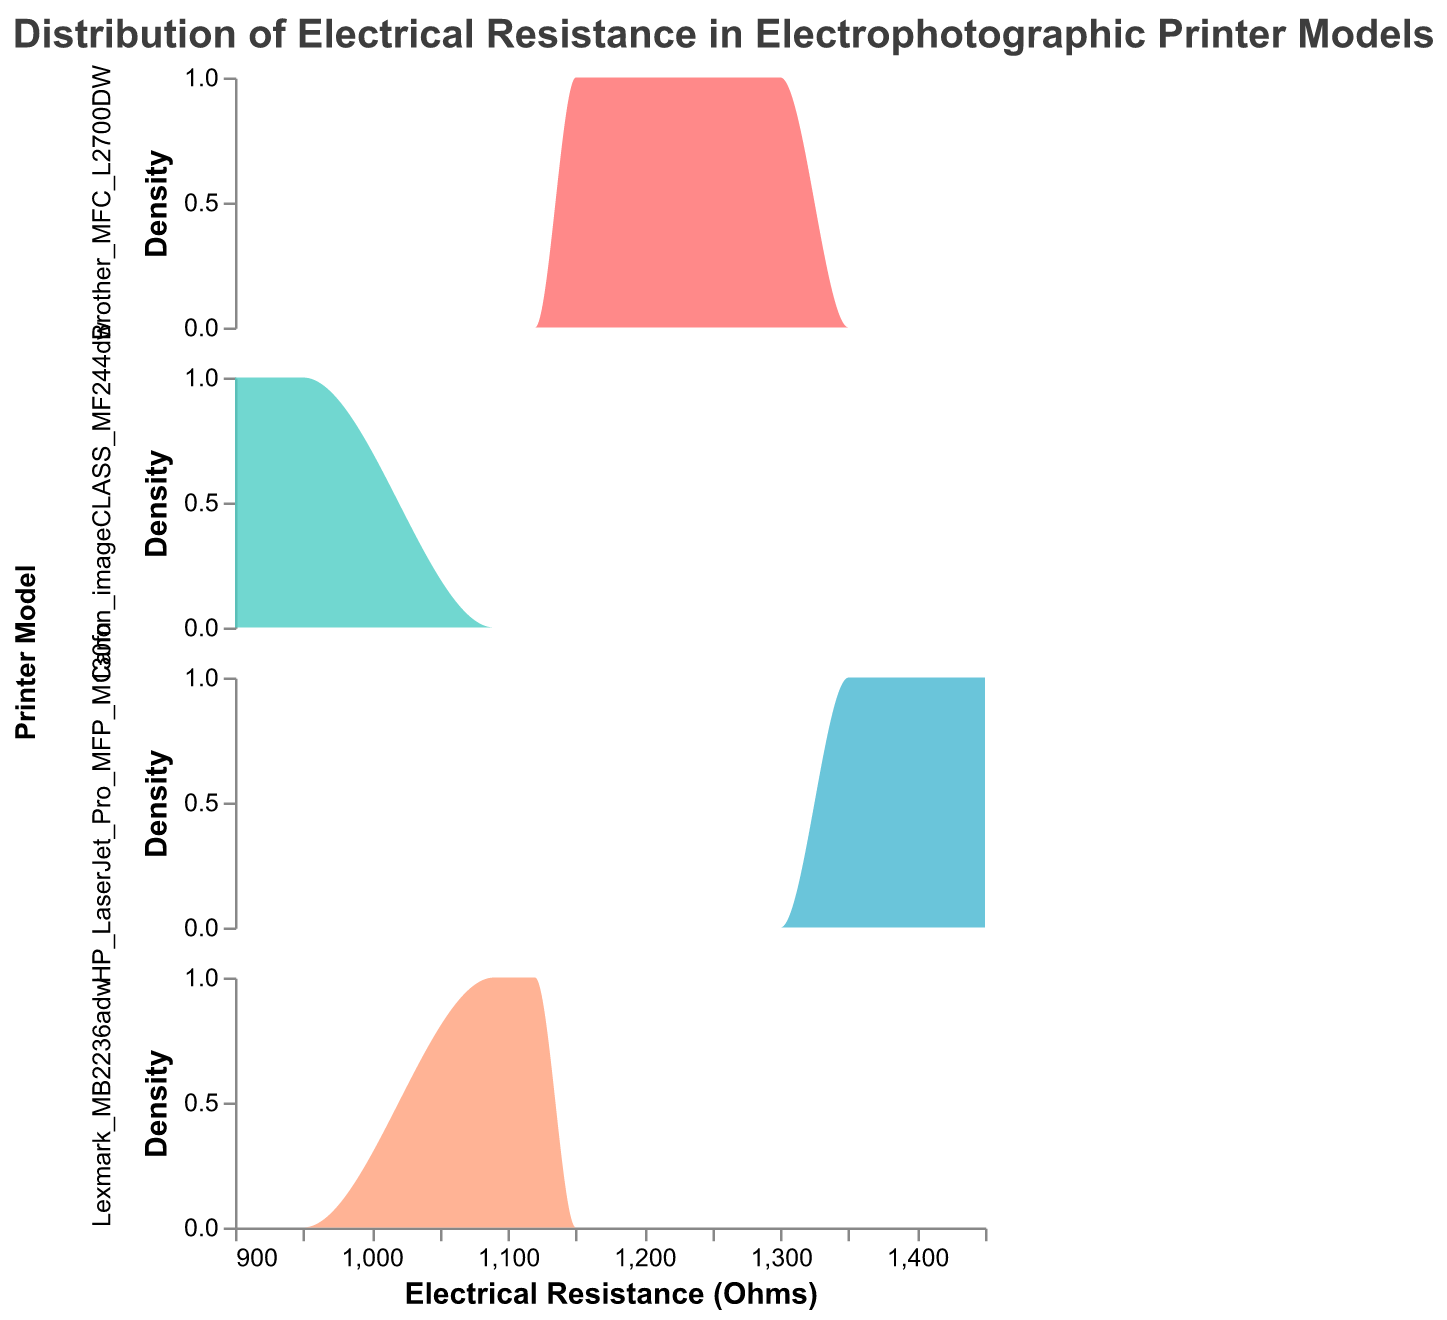What is the title of the figure? The title of the figure is located at the top and provides a brief description of the content displayed.
Answer: Distribution of Electrical Resistance in Electrophotographic Printer Models How many printer models are compared in the figure? Each subplot represents one printer model. By counting the subplots, we can determine the number of models compared.
Answer: 4 What is the color used to represent the HP LaserJet Pro MFP M130fn model? The color for each model is used consistently in its respective density plot, specified in the legend or plot details.
Answer: Light blue Which model has the highest range of resistance values? By observing the x-axis of each subplot, we can see the span of resistance values covered. The model with the widest span indicates the highest range.
Answer: HP LaserJet Pro MFP M130fn What is the peak density value for the Canon imageCLASS MF244dw model? The peak density value is the highest point on the y-axis in the subplot for a particular model.
Answer: Around 1.25 Between Brother MFC L2700DW and Lexmark MB2236adw, which model shows higher variability in resistance? Variability can be assessed by the spread and shape of the density curve. A wider spread indicates higher variability.
Answer: Brother MFC L2700DW Which resistance value is most frequent for the Lexmark MB2236adw model? The resistance value corresponding to the highest point on the density curve signifies the most frequent value.
Answer: 1100 Do any models have overlapping resistance values? Overlapping resistance values are identified if the same x-axis values appear within the density plots of different models.
Answer: Yes What is the average resistance value for the Brother MFC L2700DW model? Sum the resistances for Brother MFC L2700DW and divide by the number of points: (1200 + 1300 + 1150 + 1250) / 4
Answer: 1225 Is there any model whose resistance values are all below 1000 ohms? By checking the x-axis range of each subplot, determine if any model's resistance values fall entirely below 1000 ohms.
Answer: Canon imageCLASS MF244dw 